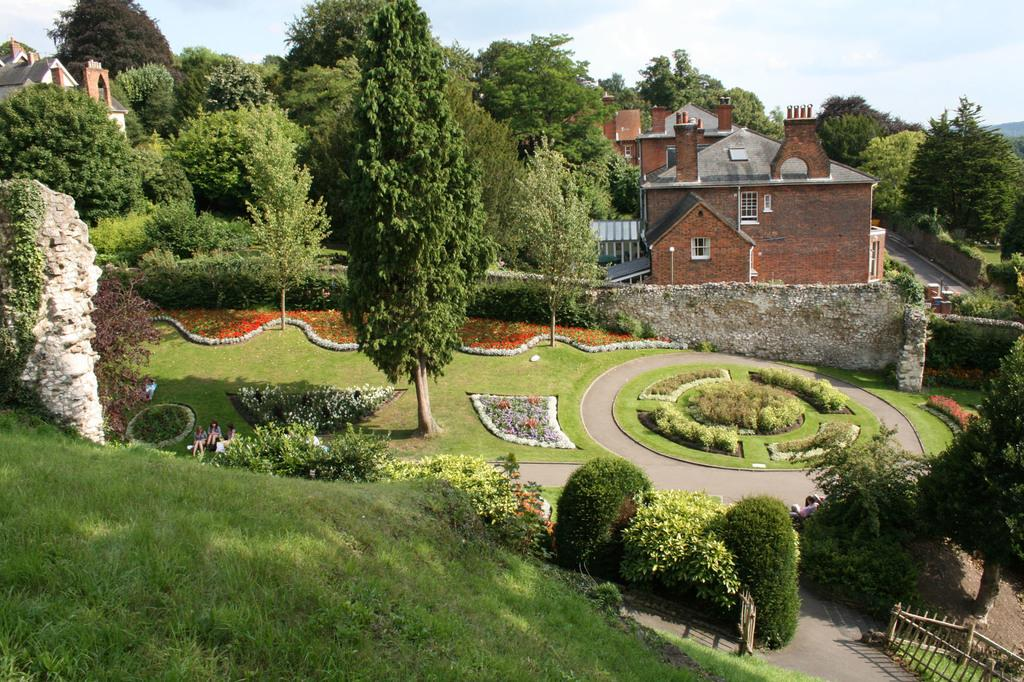What type of structures can be seen in the image? There are houses in the image. What other natural elements are present in the image? There are plants, trees, and grass visible in the image. Are there any living beings in the image? Yes, there are people in the image. What is the ground surface like in the image? The ground is visible in the image, and there is grass on it. What is the condition of the sky in the image? The sky is visible in the image, and there are clouds present. What type of clock can be seen hanging from the tree in the image? There is no clock present in the image; it only features houses, plants, trees, people, grass, a fence, and the sky with clouds. What ornament is being used by the people in the image while they are reading? There is no mention of reading or ornaments in the image; it only shows houses, plants, trees, people, grass, a fence, and the sky with clouds. 